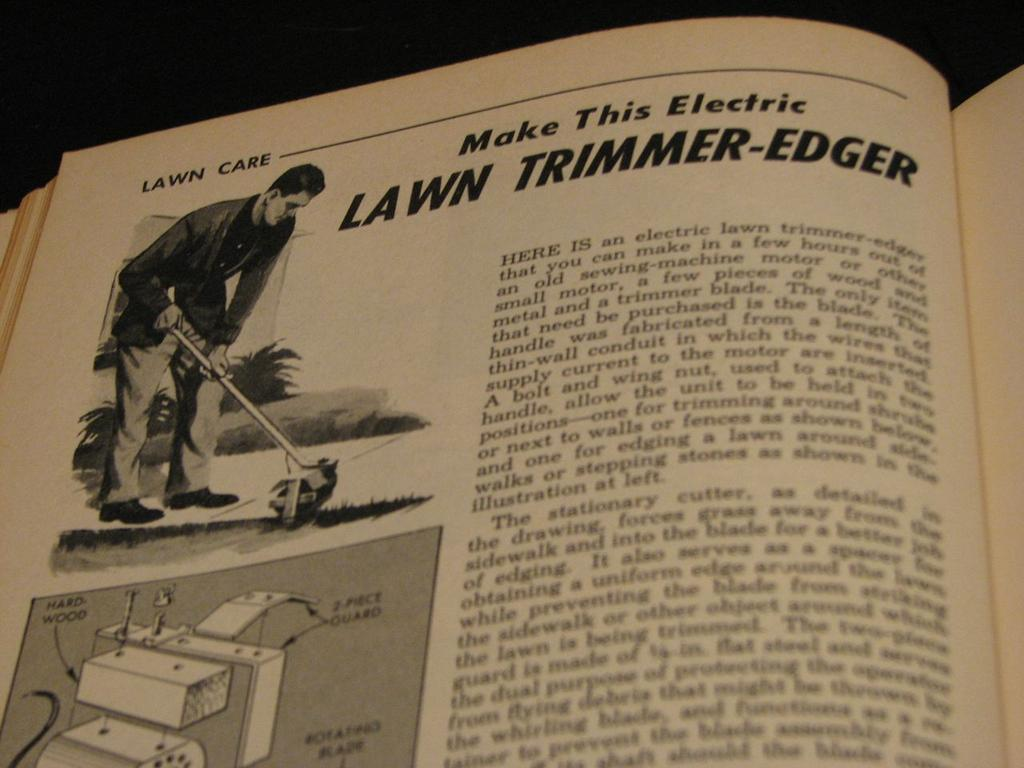<image>
Render a clear and concise summary of the photo. A book is opened to a page describing an electric lawn trimmer-edger. 